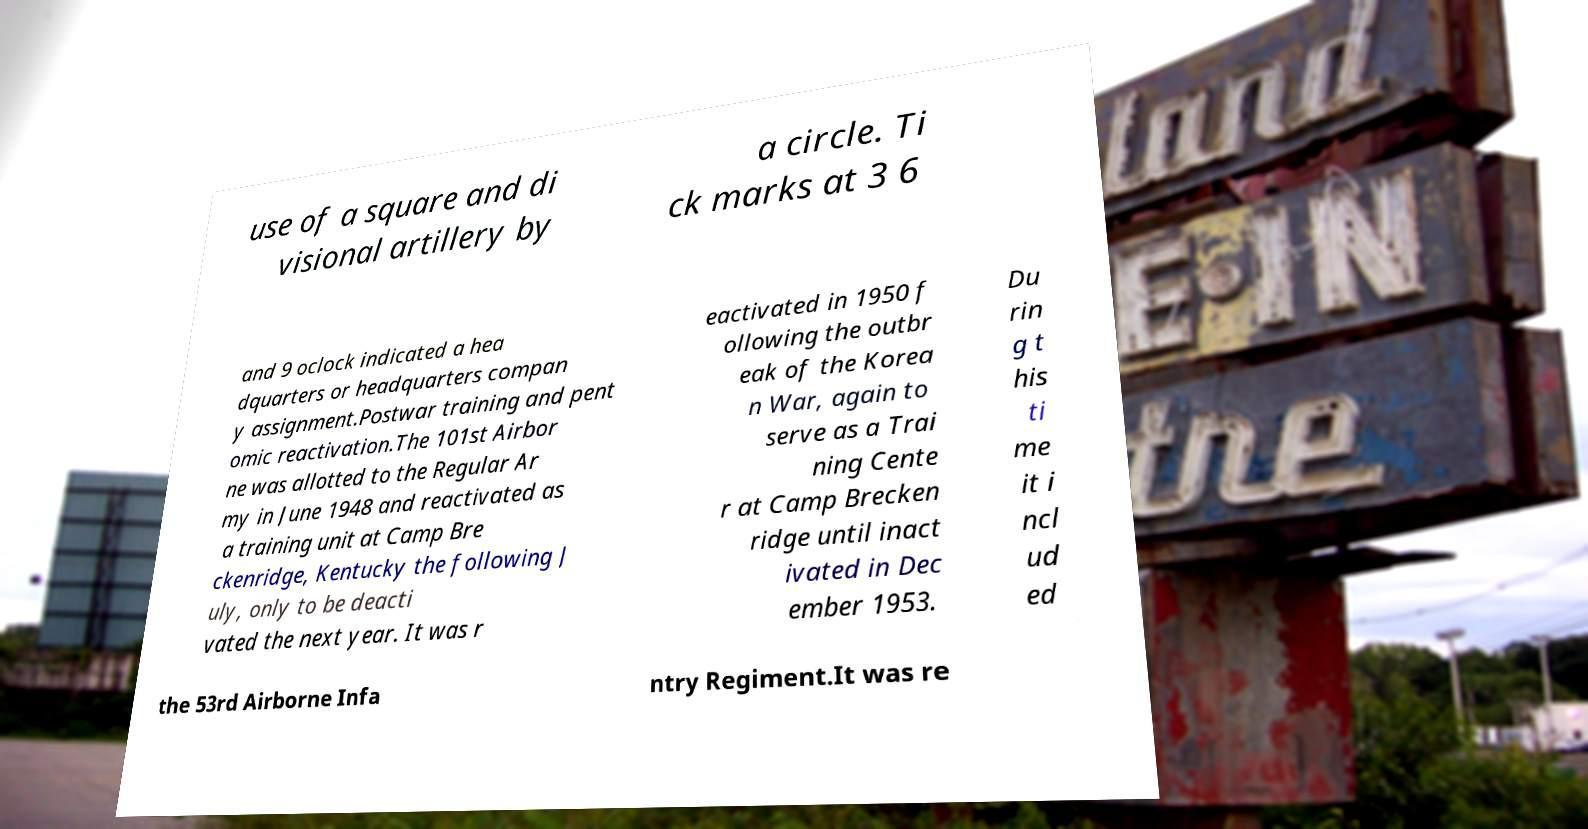There's text embedded in this image that I need extracted. Can you transcribe it verbatim? use of a square and di visional artillery by a circle. Ti ck marks at 3 6 and 9 oclock indicated a hea dquarters or headquarters compan y assignment.Postwar training and pent omic reactivation.The 101st Airbor ne was allotted to the Regular Ar my in June 1948 and reactivated as a training unit at Camp Bre ckenridge, Kentucky the following J uly, only to be deacti vated the next year. It was r eactivated in 1950 f ollowing the outbr eak of the Korea n War, again to serve as a Trai ning Cente r at Camp Brecken ridge until inact ivated in Dec ember 1953. Du rin g t his ti me it i ncl ud ed the 53rd Airborne Infa ntry Regiment.It was re 